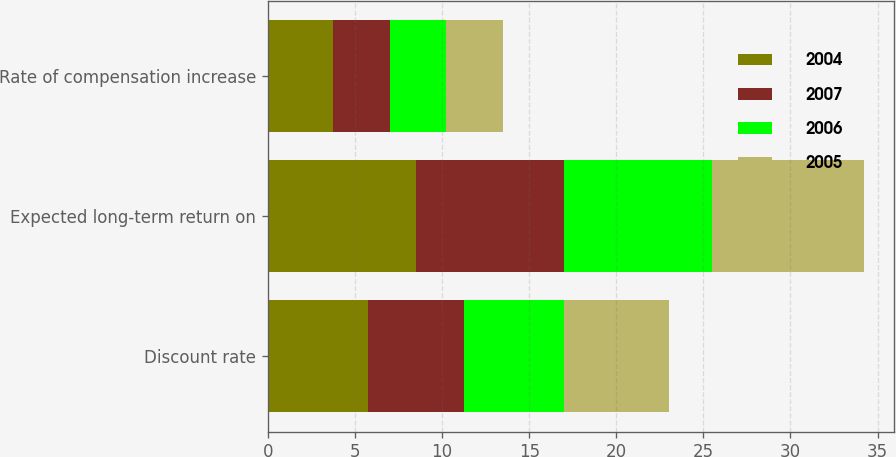Convert chart to OTSL. <chart><loc_0><loc_0><loc_500><loc_500><stacked_bar_chart><ecel><fcel>Discount rate<fcel>Expected long-term return on<fcel>Rate of compensation increase<nl><fcel>2004<fcel>5.75<fcel>8.5<fcel>3.75<nl><fcel>2007<fcel>5.5<fcel>8.5<fcel>3.25<nl><fcel>2006<fcel>5.75<fcel>8.5<fcel>3.25<nl><fcel>2005<fcel>6<fcel>8.75<fcel>3.25<nl></chart> 